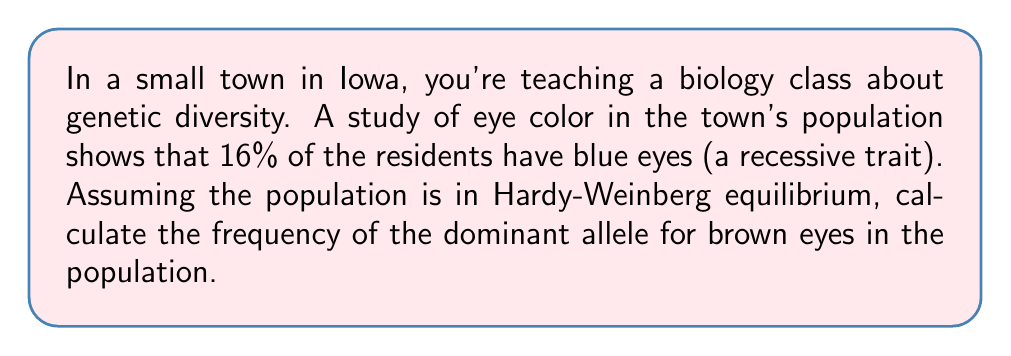Provide a solution to this math problem. To solve this problem, we'll use the Hardy-Weinberg principle. Let's break it down step-by-step:

1) Let's define our variables:
   $p$ = frequency of the dominant allele (brown eyes)
   $q$ = frequency of the recessive allele (blue eyes)

2) We know that $p + q = 1$ (the sum of all allele frequencies must equal 1)

3) In Hardy-Weinberg equilibrium, the frequency of the recessive phenotype (blue eyes) is equal to $q^2$. We're given that 16% of the population has blue eyes, so:

   $q^2 = 0.16$

4) To find $q$, we take the square root of both sides:

   $q = \sqrt{0.16} = 0.4$

5) Now that we know $q$, we can find $p$ using the equation from step 2:

   $p + q = 1$
   $p + 0.4 = 1$
   $p = 1 - 0.4 = 0.6$

Therefore, the frequency of the dominant allele (brown eyes) in the population is 0.6 or 60%.

To verify, we can check if these frequencies satisfy the Hardy-Weinberg equation:

$p^2 + 2pq + q^2 = 1$

$(0.6)^2 + 2(0.6)(0.4) + (0.4)^2 = 0.36 + 0.48 + 0.16 = 1$

This confirms that our calculation is correct and the population is in Hardy-Weinberg equilibrium.
Answer: The frequency of the dominant allele for brown eyes in the population is 0.6 or 60%. 